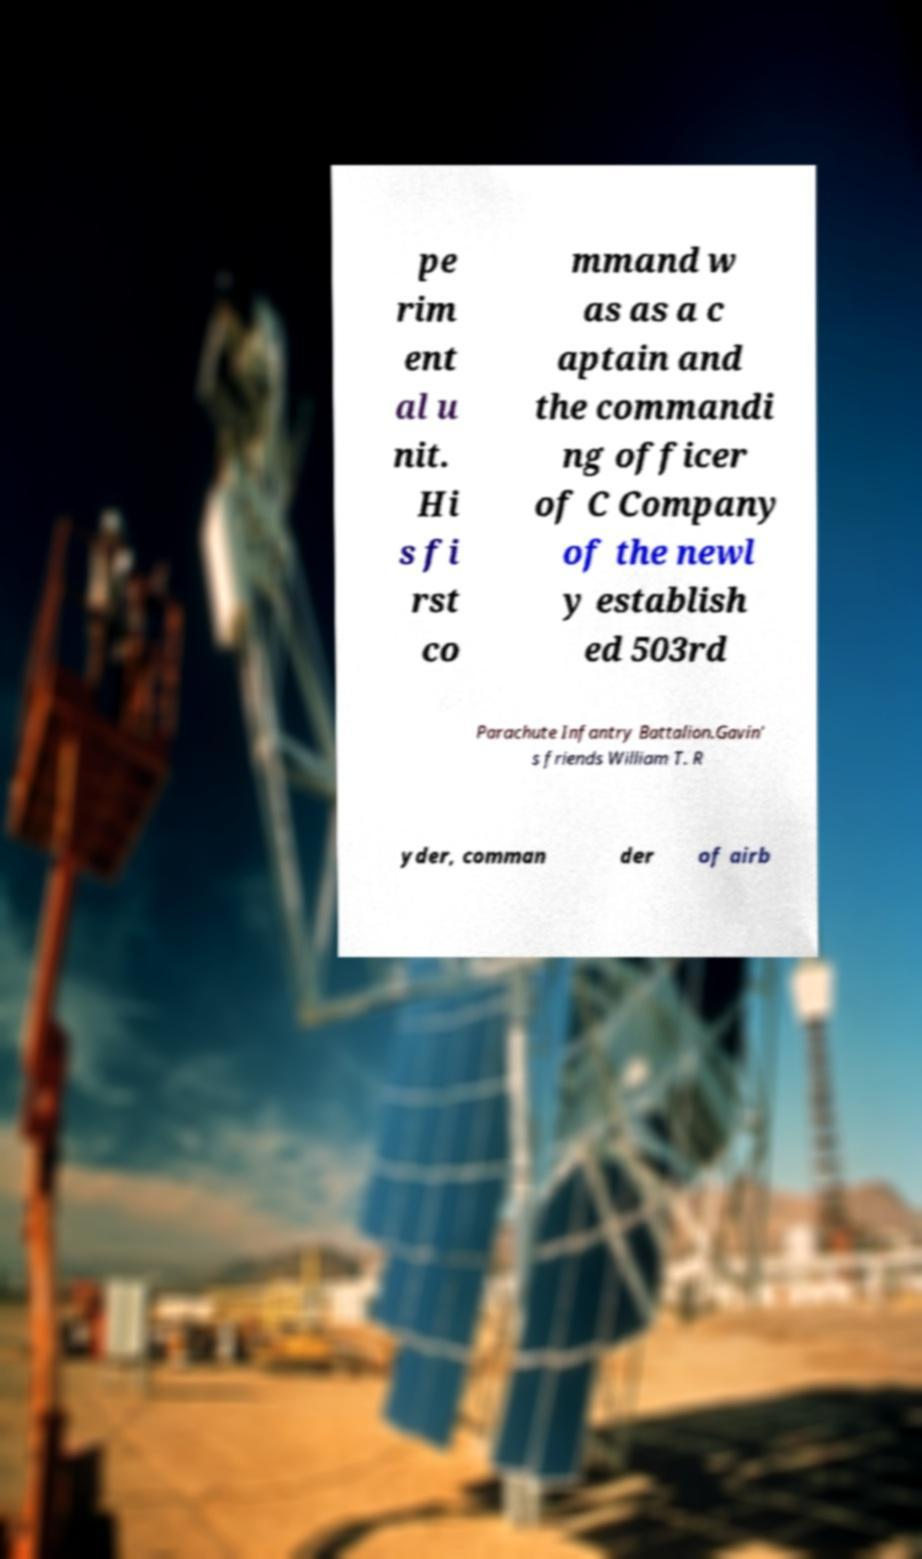I need the written content from this picture converted into text. Can you do that? pe rim ent al u nit. Hi s fi rst co mmand w as as a c aptain and the commandi ng officer of C Company of the newl y establish ed 503rd Parachute Infantry Battalion.Gavin' s friends William T. R yder, comman der of airb 